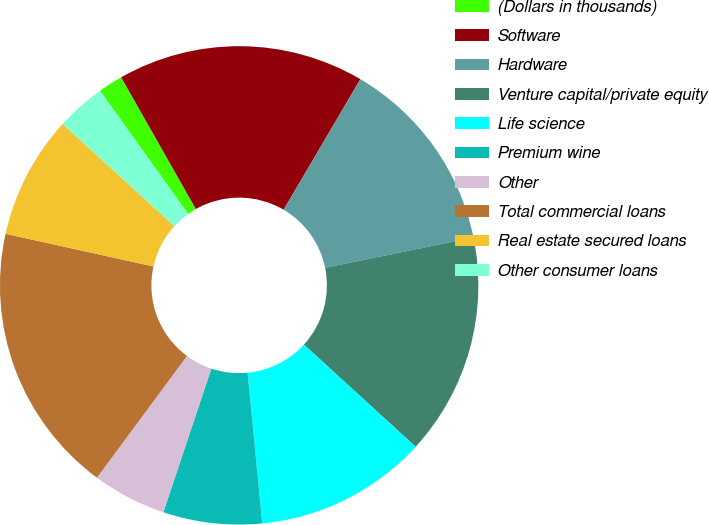Convert chart to OTSL. <chart><loc_0><loc_0><loc_500><loc_500><pie_chart><fcel>(Dollars in thousands)<fcel>Software<fcel>Hardware<fcel>Venture capital/private equity<fcel>Life science<fcel>Premium wine<fcel>Other<fcel>Total commercial loans<fcel>Real estate secured loans<fcel>Other consumer loans<nl><fcel>1.67%<fcel>16.67%<fcel>13.33%<fcel>15.0%<fcel>11.67%<fcel>6.67%<fcel>5.0%<fcel>18.33%<fcel>8.33%<fcel>3.33%<nl></chart> 